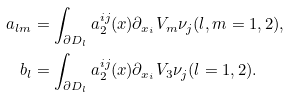Convert formula to latex. <formula><loc_0><loc_0><loc_500><loc_500>a _ { l m } & = \int _ { \partial D _ { l } } a _ { 2 } ^ { i j } ( x ) \partial _ { x _ { i } } { V _ { m } } \nu _ { j } ( l , m = 1 , 2 ) , \\ b _ { l } & = \int _ { \partial D _ { l } } a _ { 2 } ^ { i j } ( x ) \partial _ { x _ { i } } { V _ { 3 } } \nu _ { j } ( l = 1 , 2 ) .</formula> 